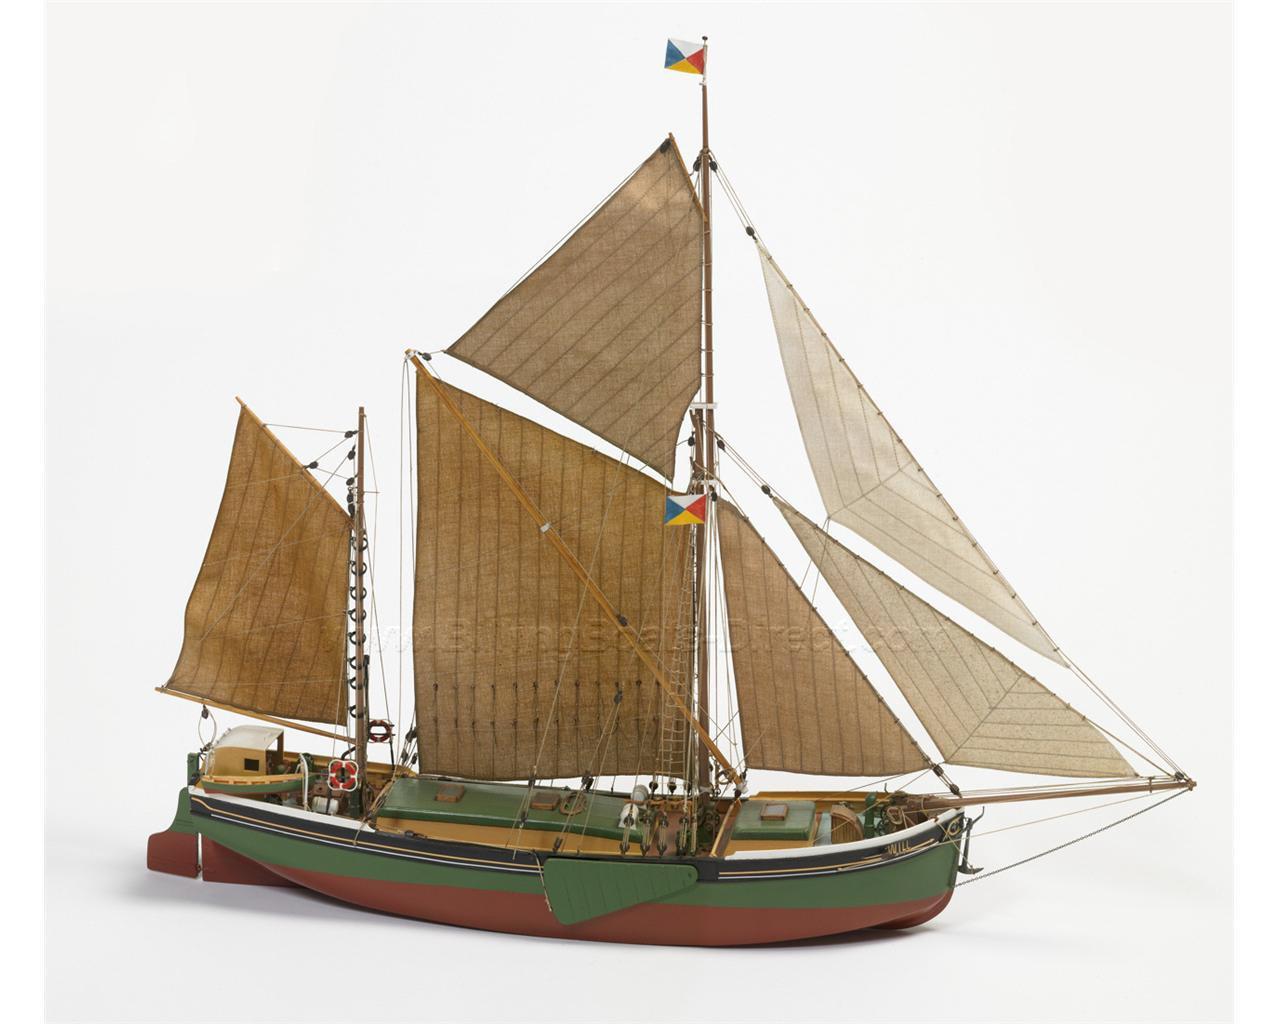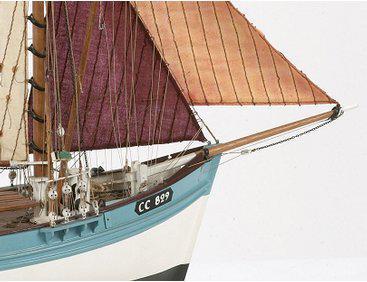The first image is the image on the left, the second image is the image on the right. Examine the images to the left and right. Is the description "The boat in one of the images has exactly 6 sails" accurate? Answer yes or no. Yes. 